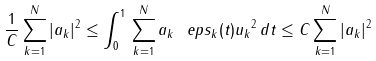<formula> <loc_0><loc_0><loc_500><loc_500>\frac { 1 } { C } \sum _ { k = 1 } ^ { N } | a _ { k } | ^ { 2 } \leq \int _ { 0 } ^ { 1 } \| \sum _ { k = 1 } ^ { N } a _ { k } \ e p s _ { k } ( t ) u _ { k } \| ^ { 2 } \, d t \leq C \sum _ { k = 1 } ^ { N } | a _ { k } | ^ { 2 }</formula> 